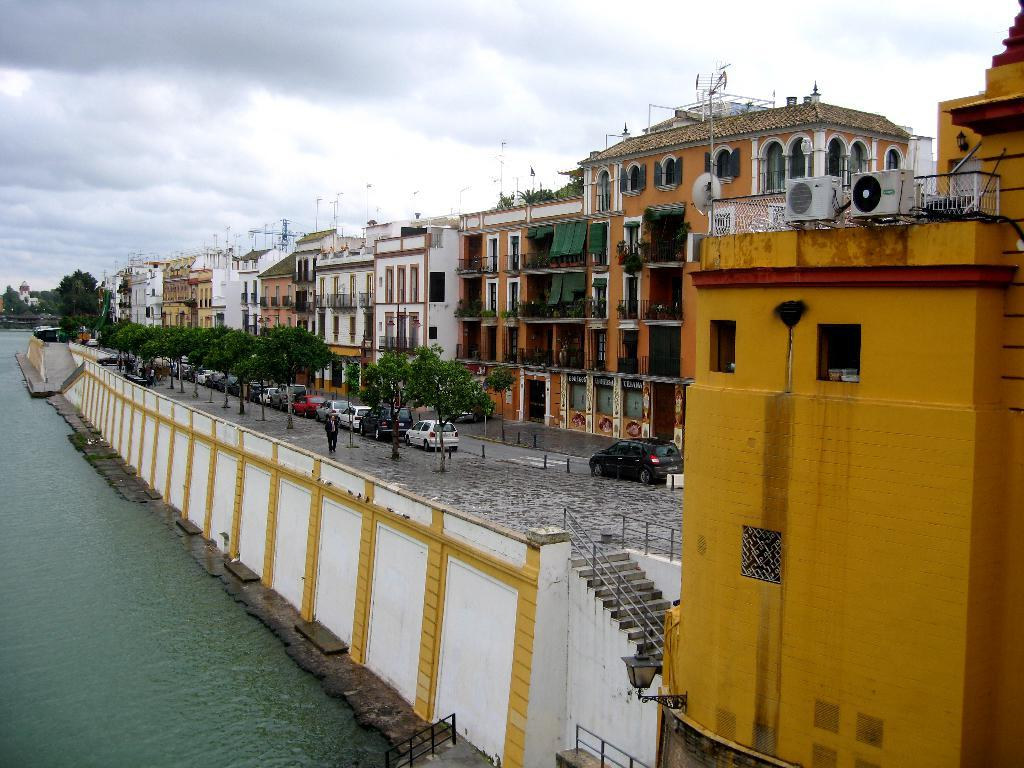What type of structures can be seen in the image? There are buildings in the image. What other natural elements are present in the image? There are trees in the image. What mode of transportation can be seen on the road in the image? There are cars on the road in the image. What body of water is visible on the left side of the image? There is a lake on the left side of the image. What is the condition of the sky in the image? The sky is covered with clouds. What theory is being discussed by the servant in the image? There is no servant or discussion of a theory present in the image. What activity is the lake involved in within the image? The lake is not involved in any activity within the image; it is a stationary body of water. 